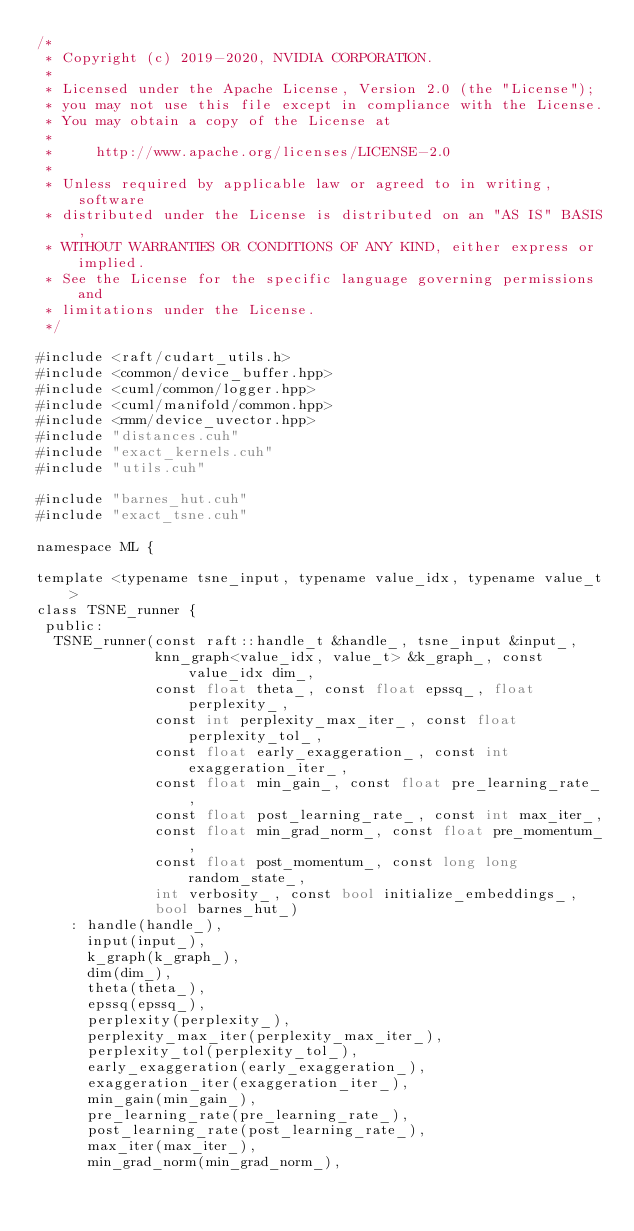Convert code to text. <code><loc_0><loc_0><loc_500><loc_500><_Cuda_>/*
 * Copyright (c) 2019-2020, NVIDIA CORPORATION.
 *
 * Licensed under the Apache License, Version 2.0 (the "License");
 * you may not use this file except in compliance with the License.
 * You may obtain a copy of the License at
 *
 *     http://www.apache.org/licenses/LICENSE-2.0
 *
 * Unless required by applicable law or agreed to in writing, software
 * distributed under the License is distributed on an "AS IS" BASIS,
 * WITHOUT WARRANTIES OR CONDITIONS OF ANY KIND, either express or implied.
 * See the License for the specific language governing permissions and
 * limitations under the License.
 */

#include <raft/cudart_utils.h>
#include <common/device_buffer.hpp>
#include <cuml/common/logger.hpp>
#include <cuml/manifold/common.hpp>
#include <rmm/device_uvector.hpp>
#include "distances.cuh"
#include "exact_kernels.cuh"
#include "utils.cuh"

#include "barnes_hut.cuh"
#include "exact_tsne.cuh"

namespace ML {

template <typename tsne_input, typename value_idx, typename value_t>
class TSNE_runner {
 public:
  TSNE_runner(const raft::handle_t &handle_, tsne_input &input_,
              knn_graph<value_idx, value_t> &k_graph_, const value_idx dim_,
              const float theta_, const float epssq_, float perplexity_,
              const int perplexity_max_iter_, const float perplexity_tol_,
              const float early_exaggeration_, const int exaggeration_iter_,
              const float min_gain_, const float pre_learning_rate_,
              const float post_learning_rate_, const int max_iter_,
              const float min_grad_norm_, const float pre_momentum_,
              const float post_momentum_, const long long random_state_,
              int verbosity_, const bool initialize_embeddings_,
              bool barnes_hut_)
    : handle(handle_),
      input(input_),
      k_graph(k_graph_),
      dim(dim_),
      theta(theta_),
      epssq(epssq_),
      perplexity(perplexity_),
      perplexity_max_iter(perplexity_max_iter_),
      perplexity_tol(perplexity_tol_),
      early_exaggeration(early_exaggeration_),
      exaggeration_iter(exaggeration_iter_),
      min_gain(min_gain_),
      pre_learning_rate(pre_learning_rate_),
      post_learning_rate(post_learning_rate_),
      max_iter(max_iter_),
      min_grad_norm(min_grad_norm_),</code> 